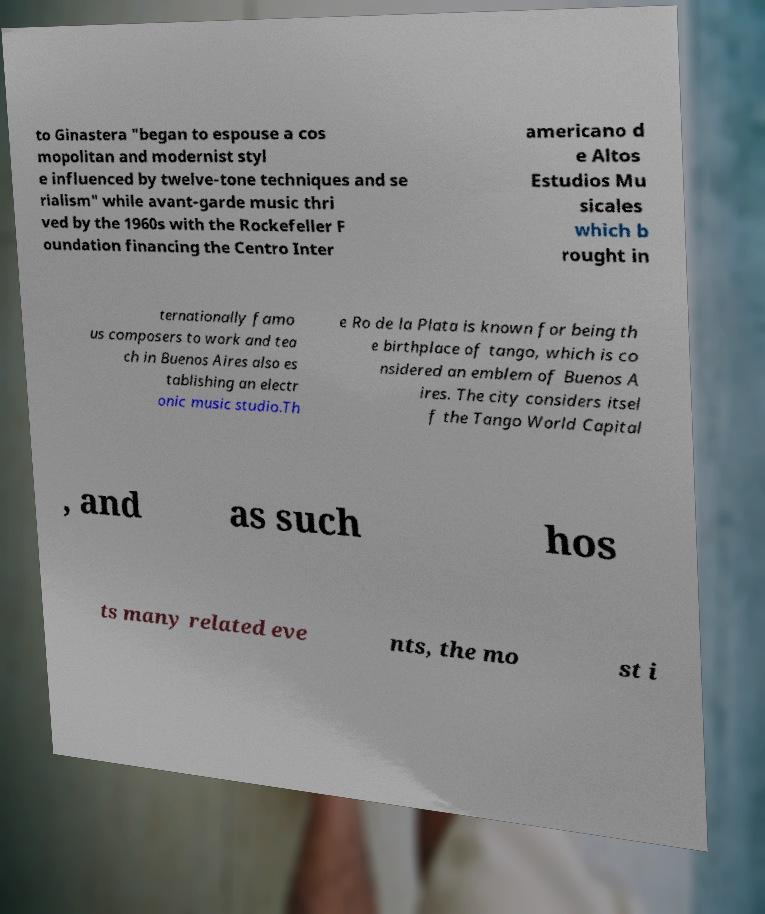Please identify and transcribe the text found in this image. to Ginastera "began to espouse a cos mopolitan and modernist styl e influenced by twelve-tone techniques and se rialism" while avant-garde music thri ved by the 1960s with the Rockefeller F oundation financing the Centro Inter americano d e Altos Estudios Mu sicales which b rought in ternationally famo us composers to work and tea ch in Buenos Aires also es tablishing an electr onic music studio.Th e Ro de la Plata is known for being th e birthplace of tango, which is co nsidered an emblem of Buenos A ires. The city considers itsel f the Tango World Capital , and as such hos ts many related eve nts, the mo st i 